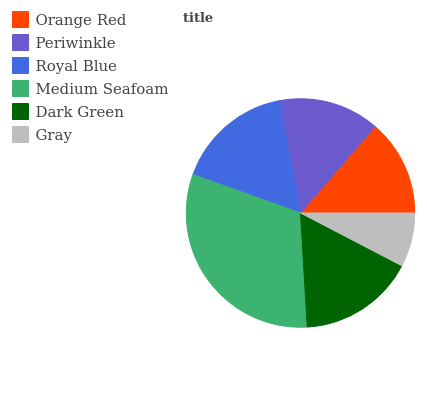Is Gray the minimum?
Answer yes or no. Yes. Is Medium Seafoam the maximum?
Answer yes or no. Yes. Is Periwinkle the minimum?
Answer yes or no. No. Is Periwinkle the maximum?
Answer yes or no. No. Is Periwinkle greater than Orange Red?
Answer yes or no. Yes. Is Orange Red less than Periwinkle?
Answer yes or no. Yes. Is Orange Red greater than Periwinkle?
Answer yes or no. No. Is Periwinkle less than Orange Red?
Answer yes or no. No. Is Dark Green the high median?
Answer yes or no. Yes. Is Periwinkle the low median?
Answer yes or no. Yes. Is Periwinkle the high median?
Answer yes or no. No. Is Royal Blue the low median?
Answer yes or no. No. 